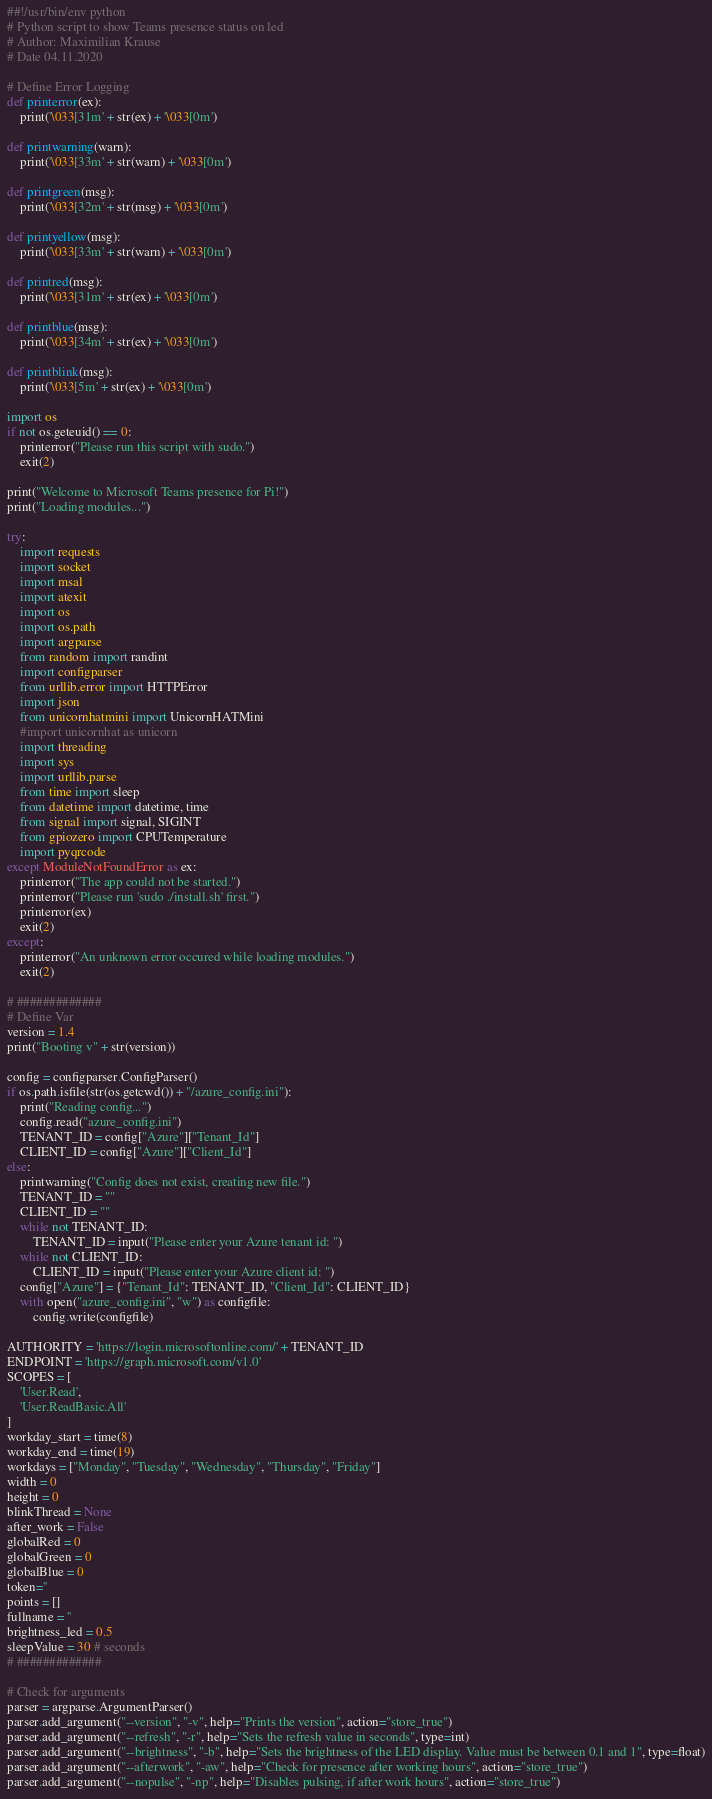Convert code to text. <code><loc_0><loc_0><loc_500><loc_500><_Python_>##!/usr/bin/env python
# Python script to show Teams presence status on led
# Author: Maximilian Krause
# Date 04.11.2020

# Define Error Logging
def printerror(ex):
	print('\033[31m' + str(ex) + '\033[0m')

def printwarning(warn):
	print('\033[33m' + str(warn) + '\033[0m')

def printgreen(msg):
	print('\033[32m' + str(msg) + '\033[0m')

def printyellow(msg):
	print('\033[33m' + str(warn) + '\033[0m')

def printred(msg):
	print('\033[31m' + str(ex) + '\033[0m')

def printblue(msg):
	print('\033[34m' + str(ex) + '\033[0m')

def printblink(msg):
	print('\033[5m' + str(ex) + '\033[0m')

import os
if not os.geteuid() == 0:
	printerror("Please run this script with sudo.")
	exit(2)

print("Welcome to Microsoft Teams presence for Pi!")
print("Loading modules...")

try:
	import requests
	import socket
	import msal
	import atexit
	import os
	import os.path
	import argparse
	from random import randint
	import configparser
	from urllib.error import HTTPError
	import json
	from unicornhatmini import UnicornHATMini 
	#import unicornhat as unicorn
	import threading
	import sys
	import urllib.parse
	from time import sleep
	from datetime import datetime, time
	from signal import signal, SIGINT
	from gpiozero import CPUTemperature
	import pyqrcode
except ModuleNotFoundError as ex:
	printerror("The app could not be started.")
	printerror("Please run 'sudo ./install.sh' first.")
	printerror(ex)
	exit(2)
except:
	printerror("An unknown error occured while loading modules.")
	exit(2)

# #############
# Define Var
version = 1.4
print("Booting v" + str(version))

config = configparser.ConfigParser()
if os.path.isfile(str(os.getcwd()) + "/azure_config.ini"):
	print("Reading config...")
	config.read("azure_config.ini")
	TENANT_ID = config["Azure"]["Tenant_Id"]
	CLIENT_ID = config["Azure"]["Client_Id"]
else:
	printwarning("Config does not exist, creating new file.")
	TENANT_ID = ""
	CLIENT_ID = ""
	while not TENANT_ID:
		TENANT_ID = input("Please enter your Azure tenant id: ")
	while not CLIENT_ID:
		CLIENT_ID = input("Please enter your Azure client id: ")
	config["Azure"] = {"Tenant_Id": TENANT_ID, "Client_Id": CLIENT_ID}
	with open("azure_config.ini", "w") as configfile:
		config.write(configfile)

AUTHORITY = 'https://login.microsoftonline.com/' + TENANT_ID
ENDPOINT = 'https://graph.microsoft.com/v1.0'
SCOPES = [
    'User.Read',
    'User.ReadBasic.All'
]
workday_start = time(8)
workday_end = time(19)
workdays = ["Monday", "Tuesday", "Wednesday", "Thursday", "Friday"]
width = 0
height = 0
blinkThread = None
after_work = False
globalRed = 0
globalGreen = 0
globalBlue = 0
token=''
points = []
fullname = ''
brightness_led = 0.5
sleepValue = 30 # seconds
# #############

# Check for arguments
parser = argparse.ArgumentParser()
parser.add_argument("--version", "-v", help="Prints the version", action="store_true")
parser.add_argument("--refresh", "-r", help="Sets the refresh value in seconds", type=int)
parser.add_argument("--brightness", "-b", help="Sets the brightness of the LED display. Value must be between 0.1 and 1", type=float)
parser.add_argument("--afterwork", "-aw", help="Check for presence after working hours", action="store_true")
parser.add_argument("--nopulse", "-np", help="Disables pulsing, if after work hours", action="store_true")</code> 